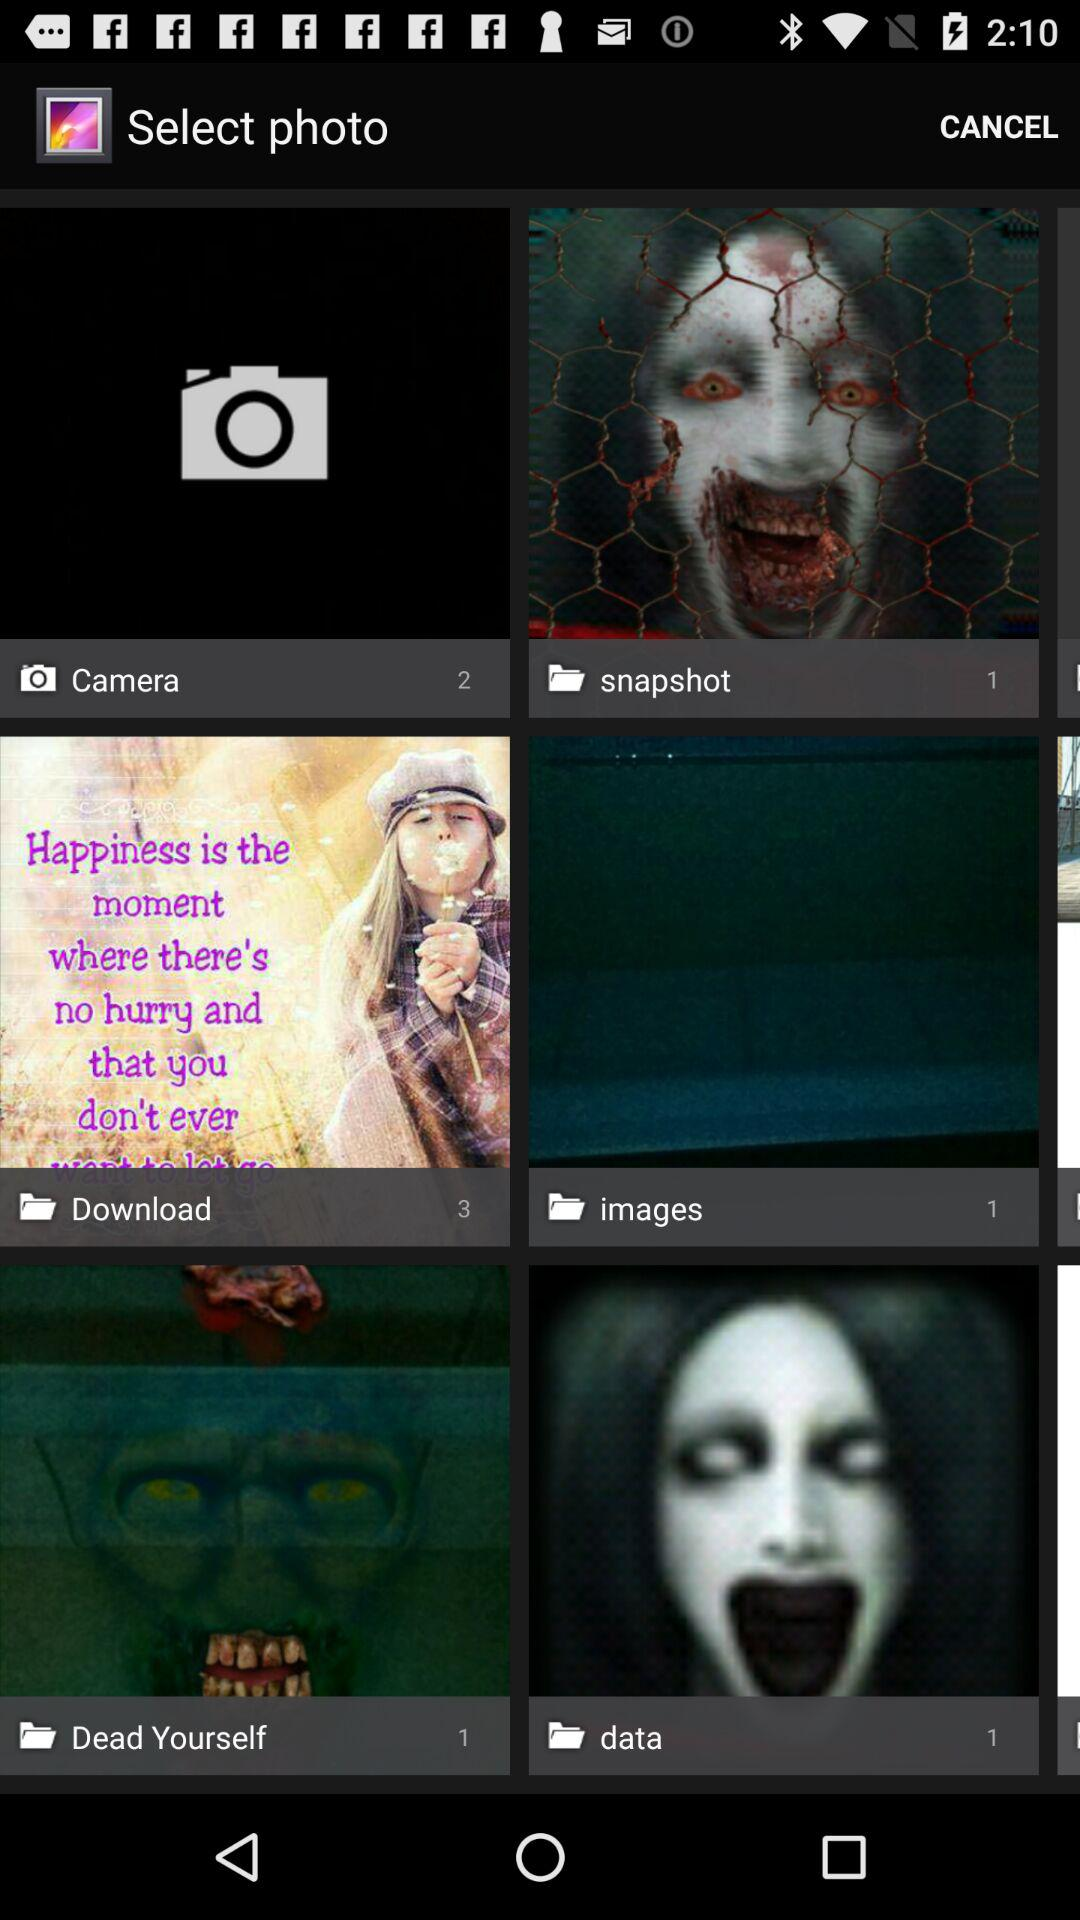Which folder contains three images? The folder is "Download". 